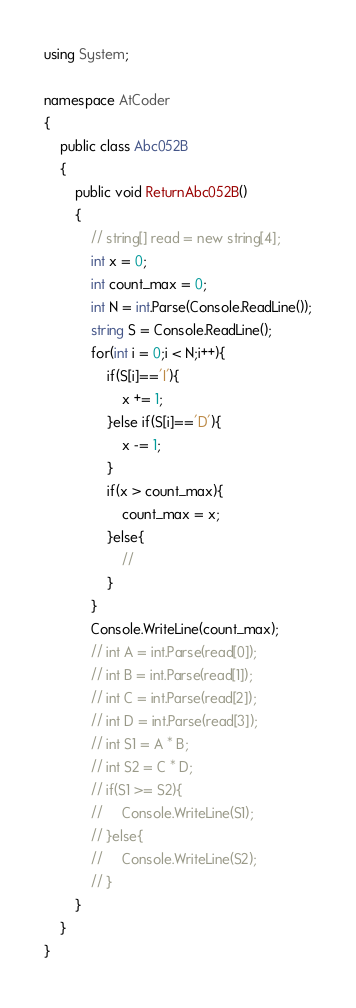Convert code to text. <code><loc_0><loc_0><loc_500><loc_500><_C#_>using System;

namespace AtCoder
{
    public class Abc052B
    {
        public void ReturnAbc052B()
        {
            // string[] read = new string[4];
            int x = 0;
            int count_max = 0;
            int N = int.Parse(Console.ReadLine());
            string S = Console.ReadLine();
            for(int i = 0;i < N;i++){
                if(S[i]=='I'){
                    x += 1;
                }else if(S[i]=='D'){
                    x -= 1;
                }
                if(x > count_max){
                    count_max = x;
                }else{
                    //
                }
            }
            Console.WriteLine(count_max);
            // int A = int.Parse(read[0]);
            // int B = int.Parse(read[1]);
            // int C = int.Parse(read[2]);
            // int D = int.Parse(read[3]);
            // int S1 = A * B;
            // int S2 = C * D;
            // if(S1 >= S2){
            //     Console.WriteLine(S1);
            // }else{
            //     Console.WriteLine(S2);
            // }
        }
    }
}</code> 